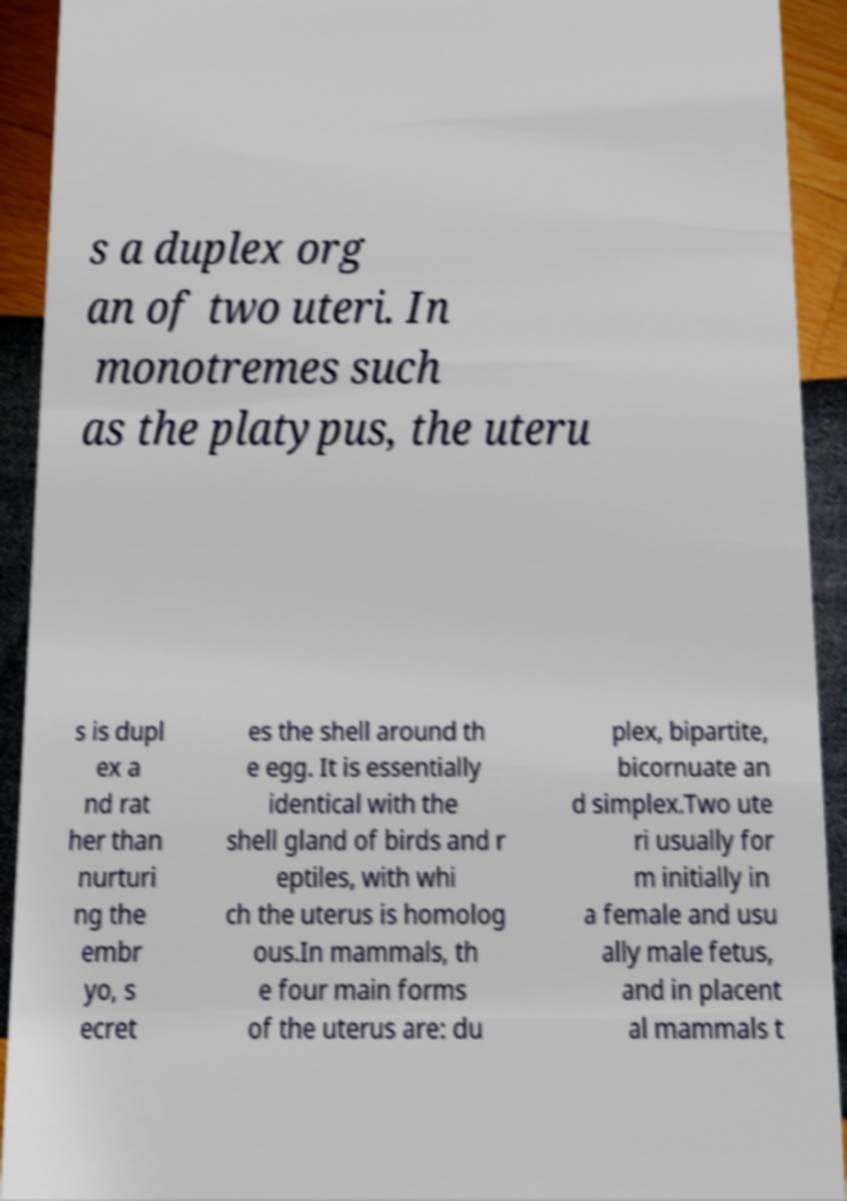Could you extract and type out the text from this image? s a duplex org an of two uteri. In monotremes such as the platypus, the uteru s is dupl ex a nd rat her than nurturi ng the embr yo, s ecret es the shell around th e egg. It is essentially identical with the shell gland of birds and r eptiles, with whi ch the uterus is homolog ous.In mammals, th e four main forms of the uterus are: du plex, bipartite, bicornuate an d simplex.Two ute ri usually for m initially in a female and usu ally male fetus, and in placent al mammals t 